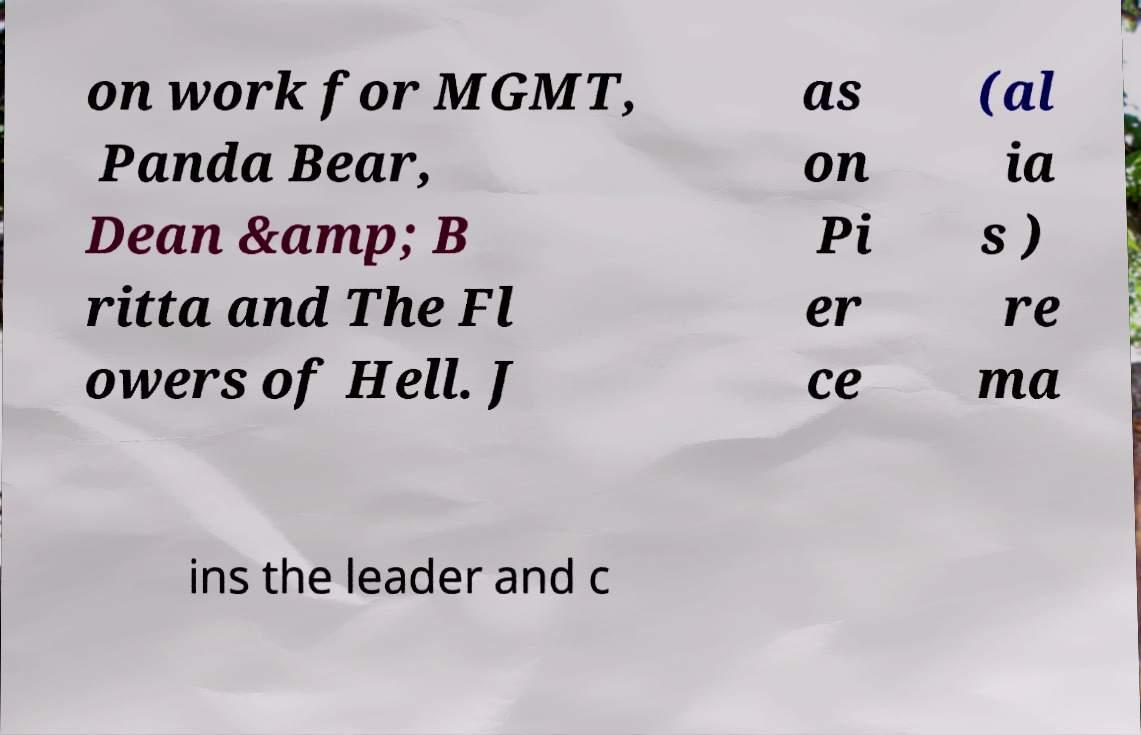For documentation purposes, I need the text within this image transcribed. Could you provide that? on work for MGMT, Panda Bear, Dean &amp; B ritta and The Fl owers of Hell. J as on Pi er ce (al ia s ) re ma ins the leader and c 